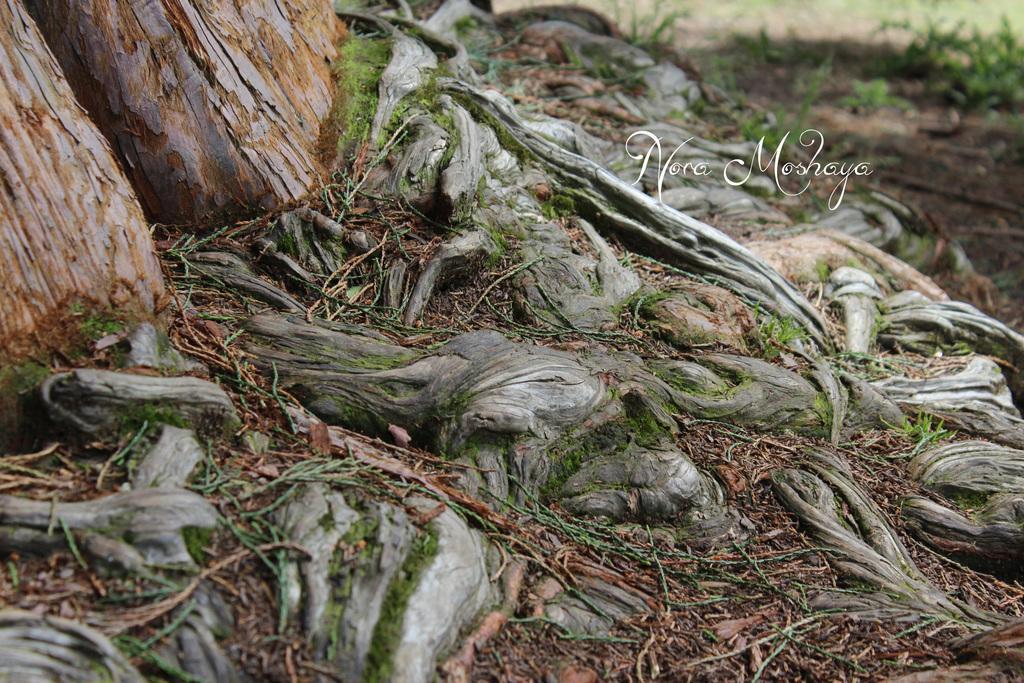Describe this image in one or two sentences. In this image we can see the tree trunks, grass and text written on the poster. 